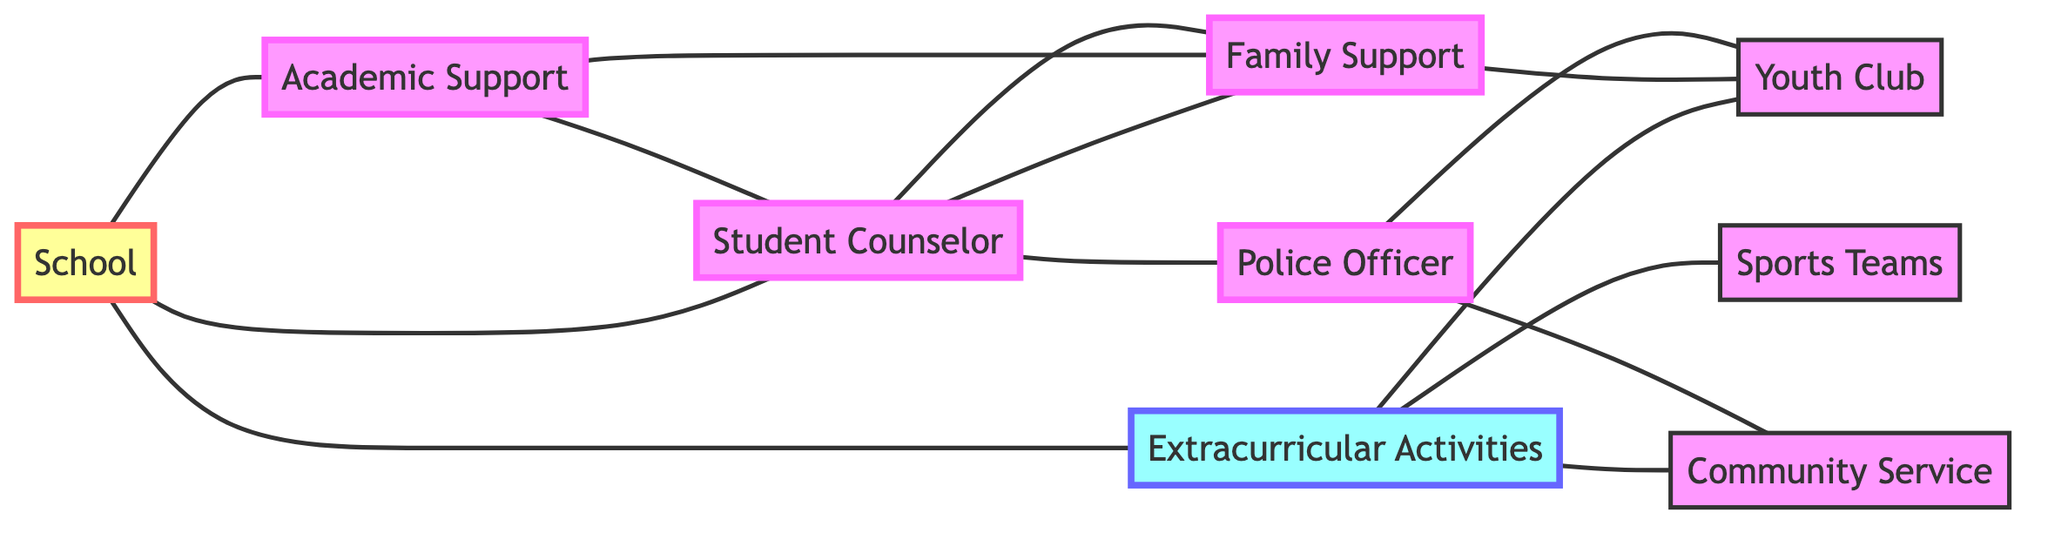What is the total number of nodes in the graph? There are 9 nodes in the graph, which include School, Extracurricular Activities, Student Counselor, Police Officer, Family Support, Youth Club, Sports Teams, Academic Support, and Community Service.
Answer: 9 Which node is connected to both the Student Counselor and Police Officer? The node that connects both the Student Counselor and Police Officer is Youth Club, as it has edges connecting to both of these nodes in the graph.
Answer: Youth Club How many edges are connected to the Extracurricular Activities node? The Extracurricular Activities node has 3 edges connecting it to Sports Teams, Youth Club, and Community Service, indicating its relationships and connections within the graph.
Answer: 3 Which node directly connects to Family Support? Family Support is directly connected to Student Counselor and Youth Club as represented by the edges leading to these two nodes in the diagram.
Answer: Student Counselor, Youth Club If a teenager is seeking academic help and family support, which nodes should they access? They should access the Academic Support node for academic help and the Family Support node for emotional and familial guidance, both shown to connect with Student Counselor in the graph.
Answer: Academic Support, Family Support 